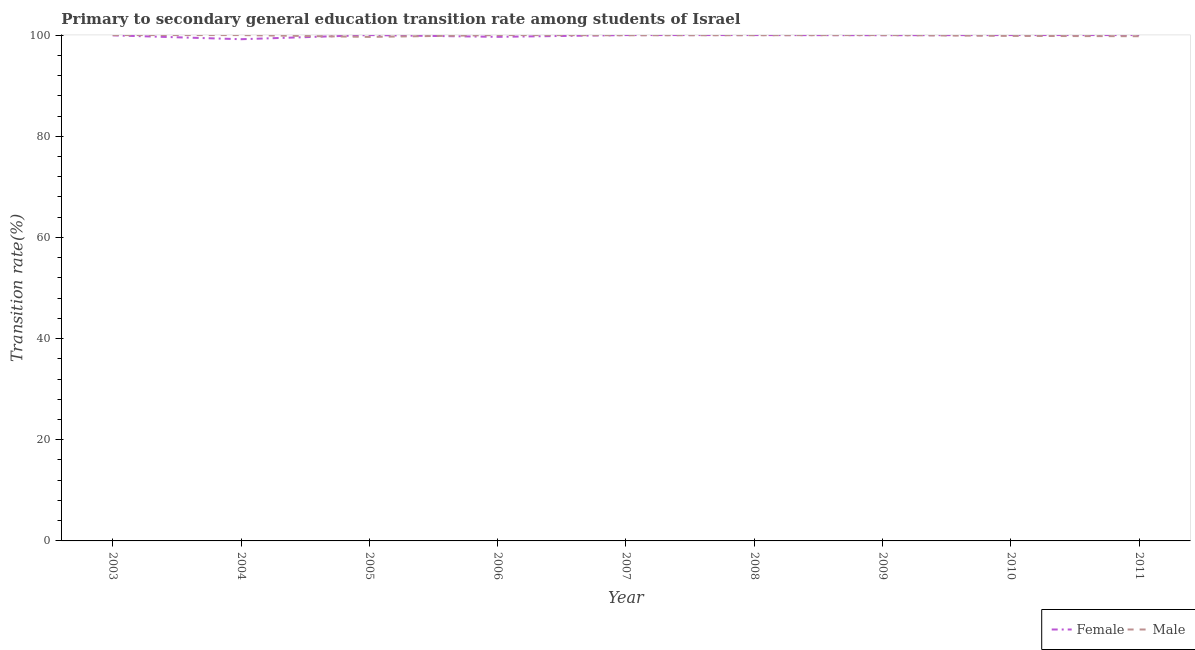How many different coloured lines are there?
Your answer should be compact. 2. Does the line corresponding to transition rate among male students intersect with the line corresponding to transition rate among female students?
Your answer should be very brief. Yes. Across all years, what is the maximum transition rate among male students?
Make the answer very short. 100. Across all years, what is the minimum transition rate among female students?
Ensure brevity in your answer.  99.18. In which year was the transition rate among female students minimum?
Make the answer very short. 2004. What is the total transition rate among male students in the graph?
Make the answer very short. 899.19. What is the difference between the transition rate among male students in 2003 and that in 2005?
Your answer should be compact. 0.36. What is the difference between the transition rate among female students in 2005 and the transition rate among male students in 2003?
Your answer should be very brief. 0. What is the average transition rate among male students per year?
Provide a succinct answer. 99.91. In the year 2008, what is the difference between the transition rate among male students and transition rate among female students?
Give a very brief answer. -0.03. In how many years, is the transition rate among male students greater than 76 %?
Provide a succinct answer. 9. What is the ratio of the transition rate among female students in 2004 to that in 2011?
Offer a very short reply. 0.99. What is the difference between the highest and the second highest transition rate among female students?
Your response must be concise. 0. What is the difference between the highest and the lowest transition rate among female students?
Offer a very short reply. 0.82. Does the transition rate among female students monotonically increase over the years?
Offer a terse response. No. Is the transition rate among male students strictly greater than the transition rate among female students over the years?
Provide a succinct answer. No. What is the difference between two consecutive major ticks on the Y-axis?
Provide a short and direct response. 20. Are the values on the major ticks of Y-axis written in scientific E-notation?
Ensure brevity in your answer.  No. Does the graph contain any zero values?
Keep it short and to the point. No. How many legend labels are there?
Offer a very short reply. 2. What is the title of the graph?
Ensure brevity in your answer.  Primary to secondary general education transition rate among students of Israel. Does "National Visitors" appear as one of the legend labels in the graph?
Provide a short and direct response. No. What is the label or title of the X-axis?
Offer a terse response. Year. What is the label or title of the Y-axis?
Offer a terse response. Transition rate(%). What is the Transition rate(%) in Female in 2003?
Your answer should be very brief. 99.95. What is the Transition rate(%) of Male in 2003?
Ensure brevity in your answer.  100. What is the Transition rate(%) in Female in 2004?
Offer a terse response. 99.18. What is the Transition rate(%) of Male in 2004?
Provide a succinct answer. 100. What is the Transition rate(%) of Male in 2005?
Offer a terse response. 99.64. What is the Transition rate(%) in Female in 2006?
Make the answer very short. 99.65. What is the Transition rate(%) of Male in 2006?
Offer a very short reply. 100. What is the Transition rate(%) in Male in 2007?
Offer a very short reply. 99.96. What is the Transition rate(%) in Female in 2008?
Your response must be concise. 100. What is the Transition rate(%) in Male in 2008?
Keep it short and to the point. 99.97. What is the Transition rate(%) in Female in 2009?
Ensure brevity in your answer.  99.97. What is the Transition rate(%) of Male in 2009?
Your answer should be very brief. 100. What is the Transition rate(%) in Male in 2010?
Provide a short and direct response. 99.84. What is the Transition rate(%) in Male in 2011?
Provide a succinct answer. 99.78. Across all years, what is the minimum Transition rate(%) of Female?
Your response must be concise. 99.18. Across all years, what is the minimum Transition rate(%) of Male?
Provide a short and direct response. 99.64. What is the total Transition rate(%) in Female in the graph?
Your answer should be compact. 898.75. What is the total Transition rate(%) in Male in the graph?
Keep it short and to the point. 899.19. What is the difference between the Transition rate(%) of Female in 2003 and that in 2004?
Offer a terse response. 0.76. What is the difference between the Transition rate(%) in Female in 2003 and that in 2005?
Your answer should be very brief. -0.05. What is the difference between the Transition rate(%) in Male in 2003 and that in 2005?
Keep it short and to the point. 0.36. What is the difference between the Transition rate(%) in Female in 2003 and that in 2006?
Your answer should be very brief. 0.3. What is the difference between the Transition rate(%) in Female in 2003 and that in 2007?
Make the answer very short. -0.05. What is the difference between the Transition rate(%) of Male in 2003 and that in 2007?
Provide a short and direct response. 0.04. What is the difference between the Transition rate(%) in Female in 2003 and that in 2008?
Your response must be concise. -0.05. What is the difference between the Transition rate(%) of Male in 2003 and that in 2008?
Offer a very short reply. 0.03. What is the difference between the Transition rate(%) in Female in 2003 and that in 2009?
Make the answer very short. -0.02. What is the difference between the Transition rate(%) of Male in 2003 and that in 2009?
Offer a very short reply. 0. What is the difference between the Transition rate(%) of Female in 2003 and that in 2010?
Make the answer very short. -0.05. What is the difference between the Transition rate(%) of Male in 2003 and that in 2010?
Provide a short and direct response. 0.16. What is the difference between the Transition rate(%) in Female in 2003 and that in 2011?
Offer a terse response. -0.05. What is the difference between the Transition rate(%) in Male in 2003 and that in 2011?
Your answer should be compact. 0.22. What is the difference between the Transition rate(%) in Female in 2004 and that in 2005?
Your response must be concise. -0.82. What is the difference between the Transition rate(%) in Male in 2004 and that in 2005?
Make the answer very short. 0.36. What is the difference between the Transition rate(%) in Female in 2004 and that in 2006?
Offer a terse response. -0.47. What is the difference between the Transition rate(%) of Male in 2004 and that in 2006?
Give a very brief answer. 0. What is the difference between the Transition rate(%) in Female in 2004 and that in 2007?
Give a very brief answer. -0.82. What is the difference between the Transition rate(%) in Male in 2004 and that in 2007?
Your answer should be very brief. 0.04. What is the difference between the Transition rate(%) of Female in 2004 and that in 2008?
Give a very brief answer. -0.82. What is the difference between the Transition rate(%) of Male in 2004 and that in 2008?
Offer a very short reply. 0.03. What is the difference between the Transition rate(%) of Female in 2004 and that in 2009?
Keep it short and to the point. -0.79. What is the difference between the Transition rate(%) of Female in 2004 and that in 2010?
Ensure brevity in your answer.  -0.82. What is the difference between the Transition rate(%) in Male in 2004 and that in 2010?
Ensure brevity in your answer.  0.16. What is the difference between the Transition rate(%) of Female in 2004 and that in 2011?
Keep it short and to the point. -0.82. What is the difference between the Transition rate(%) in Male in 2004 and that in 2011?
Offer a very short reply. 0.22. What is the difference between the Transition rate(%) of Female in 2005 and that in 2006?
Give a very brief answer. 0.35. What is the difference between the Transition rate(%) in Male in 2005 and that in 2006?
Provide a succinct answer. -0.36. What is the difference between the Transition rate(%) in Female in 2005 and that in 2007?
Keep it short and to the point. 0. What is the difference between the Transition rate(%) of Male in 2005 and that in 2007?
Offer a terse response. -0.32. What is the difference between the Transition rate(%) in Male in 2005 and that in 2008?
Your answer should be compact. -0.33. What is the difference between the Transition rate(%) in Female in 2005 and that in 2009?
Your answer should be compact. 0.03. What is the difference between the Transition rate(%) in Male in 2005 and that in 2009?
Offer a very short reply. -0.36. What is the difference between the Transition rate(%) in Female in 2005 and that in 2010?
Offer a very short reply. 0. What is the difference between the Transition rate(%) in Male in 2005 and that in 2010?
Provide a succinct answer. -0.2. What is the difference between the Transition rate(%) of Female in 2005 and that in 2011?
Your response must be concise. 0. What is the difference between the Transition rate(%) of Male in 2005 and that in 2011?
Make the answer very short. -0.14. What is the difference between the Transition rate(%) of Female in 2006 and that in 2007?
Your response must be concise. -0.35. What is the difference between the Transition rate(%) of Male in 2006 and that in 2007?
Make the answer very short. 0.04. What is the difference between the Transition rate(%) of Female in 2006 and that in 2008?
Ensure brevity in your answer.  -0.35. What is the difference between the Transition rate(%) in Male in 2006 and that in 2008?
Provide a short and direct response. 0.03. What is the difference between the Transition rate(%) of Female in 2006 and that in 2009?
Ensure brevity in your answer.  -0.32. What is the difference between the Transition rate(%) of Male in 2006 and that in 2009?
Provide a short and direct response. 0. What is the difference between the Transition rate(%) in Female in 2006 and that in 2010?
Ensure brevity in your answer.  -0.35. What is the difference between the Transition rate(%) of Male in 2006 and that in 2010?
Offer a very short reply. 0.16. What is the difference between the Transition rate(%) of Female in 2006 and that in 2011?
Offer a very short reply. -0.35. What is the difference between the Transition rate(%) of Male in 2006 and that in 2011?
Keep it short and to the point. 0.22. What is the difference between the Transition rate(%) of Male in 2007 and that in 2008?
Your response must be concise. -0.01. What is the difference between the Transition rate(%) of Female in 2007 and that in 2009?
Your answer should be compact. 0.03. What is the difference between the Transition rate(%) in Male in 2007 and that in 2009?
Give a very brief answer. -0.04. What is the difference between the Transition rate(%) in Female in 2007 and that in 2010?
Your response must be concise. 0. What is the difference between the Transition rate(%) of Male in 2007 and that in 2010?
Your answer should be very brief. 0.13. What is the difference between the Transition rate(%) of Female in 2007 and that in 2011?
Offer a terse response. 0. What is the difference between the Transition rate(%) in Male in 2007 and that in 2011?
Give a very brief answer. 0.19. What is the difference between the Transition rate(%) of Female in 2008 and that in 2009?
Make the answer very short. 0.03. What is the difference between the Transition rate(%) in Male in 2008 and that in 2009?
Your answer should be very brief. -0.03. What is the difference between the Transition rate(%) of Male in 2008 and that in 2010?
Provide a short and direct response. 0.14. What is the difference between the Transition rate(%) of Male in 2008 and that in 2011?
Your answer should be compact. 0.2. What is the difference between the Transition rate(%) in Female in 2009 and that in 2010?
Offer a very short reply. -0.03. What is the difference between the Transition rate(%) of Male in 2009 and that in 2010?
Make the answer very short. 0.16. What is the difference between the Transition rate(%) in Female in 2009 and that in 2011?
Your response must be concise. -0.03. What is the difference between the Transition rate(%) in Male in 2009 and that in 2011?
Give a very brief answer. 0.22. What is the difference between the Transition rate(%) of Female in 2010 and that in 2011?
Offer a terse response. 0. What is the difference between the Transition rate(%) in Male in 2010 and that in 2011?
Your response must be concise. 0.06. What is the difference between the Transition rate(%) in Female in 2003 and the Transition rate(%) in Male in 2004?
Keep it short and to the point. -0.05. What is the difference between the Transition rate(%) in Female in 2003 and the Transition rate(%) in Male in 2005?
Provide a short and direct response. 0.31. What is the difference between the Transition rate(%) of Female in 2003 and the Transition rate(%) of Male in 2006?
Provide a succinct answer. -0.05. What is the difference between the Transition rate(%) of Female in 2003 and the Transition rate(%) of Male in 2007?
Provide a succinct answer. -0.02. What is the difference between the Transition rate(%) of Female in 2003 and the Transition rate(%) of Male in 2008?
Offer a very short reply. -0.03. What is the difference between the Transition rate(%) in Female in 2003 and the Transition rate(%) in Male in 2009?
Give a very brief answer. -0.05. What is the difference between the Transition rate(%) in Female in 2003 and the Transition rate(%) in Male in 2010?
Offer a very short reply. 0.11. What is the difference between the Transition rate(%) of Female in 2003 and the Transition rate(%) of Male in 2011?
Ensure brevity in your answer.  0.17. What is the difference between the Transition rate(%) of Female in 2004 and the Transition rate(%) of Male in 2005?
Your answer should be very brief. -0.46. What is the difference between the Transition rate(%) of Female in 2004 and the Transition rate(%) of Male in 2006?
Provide a succinct answer. -0.82. What is the difference between the Transition rate(%) of Female in 2004 and the Transition rate(%) of Male in 2007?
Give a very brief answer. -0.78. What is the difference between the Transition rate(%) of Female in 2004 and the Transition rate(%) of Male in 2008?
Your answer should be compact. -0.79. What is the difference between the Transition rate(%) of Female in 2004 and the Transition rate(%) of Male in 2009?
Offer a very short reply. -0.82. What is the difference between the Transition rate(%) of Female in 2004 and the Transition rate(%) of Male in 2010?
Keep it short and to the point. -0.65. What is the difference between the Transition rate(%) of Female in 2004 and the Transition rate(%) of Male in 2011?
Offer a terse response. -0.59. What is the difference between the Transition rate(%) of Female in 2005 and the Transition rate(%) of Male in 2006?
Offer a terse response. 0. What is the difference between the Transition rate(%) in Female in 2005 and the Transition rate(%) in Male in 2007?
Your response must be concise. 0.04. What is the difference between the Transition rate(%) in Female in 2005 and the Transition rate(%) in Male in 2008?
Ensure brevity in your answer.  0.03. What is the difference between the Transition rate(%) in Female in 2005 and the Transition rate(%) in Male in 2009?
Your answer should be compact. 0. What is the difference between the Transition rate(%) of Female in 2005 and the Transition rate(%) of Male in 2010?
Offer a very short reply. 0.16. What is the difference between the Transition rate(%) in Female in 2005 and the Transition rate(%) in Male in 2011?
Your answer should be compact. 0.22. What is the difference between the Transition rate(%) in Female in 2006 and the Transition rate(%) in Male in 2007?
Give a very brief answer. -0.31. What is the difference between the Transition rate(%) of Female in 2006 and the Transition rate(%) of Male in 2008?
Make the answer very short. -0.32. What is the difference between the Transition rate(%) in Female in 2006 and the Transition rate(%) in Male in 2009?
Make the answer very short. -0.35. What is the difference between the Transition rate(%) of Female in 2006 and the Transition rate(%) of Male in 2010?
Give a very brief answer. -0.19. What is the difference between the Transition rate(%) in Female in 2006 and the Transition rate(%) in Male in 2011?
Your answer should be very brief. -0.12. What is the difference between the Transition rate(%) of Female in 2007 and the Transition rate(%) of Male in 2008?
Offer a very short reply. 0.03. What is the difference between the Transition rate(%) of Female in 2007 and the Transition rate(%) of Male in 2010?
Ensure brevity in your answer.  0.16. What is the difference between the Transition rate(%) in Female in 2007 and the Transition rate(%) in Male in 2011?
Your response must be concise. 0.22. What is the difference between the Transition rate(%) in Female in 2008 and the Transition rate(%) in Male in 2010?
Offer a very short reply. 0.16. What is the difference between the Transition rate(%) of Female in 2008 and the Transition rate(%) of Male in 2011?
Your answer should be very brief. 0.22. What is the difference between the Transition rate(%) in Female in 2009 and the Transition rate(%) in Male in 2010?
Your answer should be compact. 0.13. What is the difference between the Transition rate(%) of Female in 2009 and the Transition rate(%) of Male in 2011?
Your answer should be very brief. 0.2. What is the difference between the Transition rate(%) of Female in 2010 and the Transition rate(%) of Male in 2011?
Provide a short and direct response. 0.22. What is the average Transition rate(%) of Female per year?
Keep it short and to the point. 99.86. What is the average Transition rate(%) of Male per year?
Your answer should be very brief. 99.91. In the year 2003, what is the difference between the Transition rate(%) of Female and Transition rate(%) of Male?
Offer a very short reply. -0.05. In the year 2004, what is the difference between the Transition rate(%) of Female and Transition rate(%) of Male?
Keep it short and to the point. -0.82. In the year 2005, what is the difference between the Transition rate(%) in Female and Transition rate(%) in Male?
Your response must be concise. 0.36. In the year 2006, what is the difference between the Transition rate(%) of Female and Transition rate(%) of Male?
Offer a terse response. -0.35. In the year 2007, what is the difference between the Transition rate(%) of Female and Transition rate(%) of Male?
Make the answer very short. 0.04. In the year 2008, what is the difference between the Transition rate(%) in Female and Transition rate(%) in Male?
Give a very brief answer. 0.03. In the year 2009, what is the difference between the Transition rate(%) in Female and Transition rate(%) in Male?
Provide a short and direct response. -0.03. In the year 2010, what is the difference between the Transition rate(%) in Female and Transition rate(%) in Male?
Your response must be concise. 0.16. In the year 2011, what is the difference between the Transition rate(%) in Female and Transition rate(%) in Male?
Ensure brevity in your answer.  0.22. What is the ratio of the Transition rate(%) of Female in 2003 to that in 2004?
Give a very brief answer. 1.01. What is the ratio of the Transition rate(%) of Female in 2003 to that in 2005?
Offer a very short reply. 1. What is the ratio of the Transition rate(%) of Female in 2003 to that in 2006?
Keep it short and to the point. 1. What is the ratio of the Transition rate(%) in Male in 2003 to that in 2006?
Ensure brevity in your answer.  1. What is the ratio of the Transition rate(%) in Female in 2003 to that in 2007?
Your answer should be compact. 1. What is the ratio of the Transition rate(%) in Male in 2003 to that in 2007?
Give a very brief answer. 1. What is the ratio of the Transition rate(%) of Male in 2003 to that in 2010?
Give a very brief answer. 1. What is the ratio of the Transition rate(%) of Female in 2003 to that in 2011?
Give a very brief answer. 1. What is the ratio of the Transition rate(%) in Female in 2004 to that in 2005?
Offer a terse response. 0.99. What is the ratio of the Transition rate(%) of Male in 2004 to that in 2005?
Provide a short and direct response. 1. What is the ratio of the Transition rate(%) in Female in 2004 to that in 2006?
Offer a very short reply. 1. What is the ratio of the Transition rate(%) in Male in 2004 to that in 2008?
Your response must be concise. 1. What is the ratio of the Transition rate(%) of Male in 2004 to that in 2009?
Your answer should be very brief. 1. What is the ratio of the Transition rate(%) of Male in 2004 to that in 2010?
Your answer should be very brief. 1. What is the ratio of the Transition rate(%) of Male in 2005 to that in 2007?
Your answer should be very brief. 1. What is the ratio of the Transition rate(%) of Female in 2005 to that in 2008?
Offer a terse response. 1. What is the ratio of the Transition rate(%) in Male in 2005 to that in 2008?
Provide a succinct answer. 1. What is the ratio of the Transition rate(%) of Male in 2005 to that in 2010?
Keep it short and to the point. 1. What is the ratio of the Transition rate(%) in Male in 2005 to that in 2011?
Give a very brief answer. 1. What is the ratio of the Transition rate(%) of Female in 2006 to that in 2007?
Offer a terse response. 1. What is the ratio of the Transition rate(%) in Male in 2006 to that in 2007?
Ensure brevity in your answer.  1. What is the ratio of the Transition rate(%) of Male in 2006 to that in 2008?
Provide a short and direct response. 1. What is the ratio of the Transition rate(%) in Female in 2006 to that in 2009?
Your response must be concise. 1. What is the ratio of the Transition rate(%) of Female in 2006 to that in 2010?
Provide a succinct answer. 1. What is the ratio of the Transition rate(%) in Female in 2006 to that in 2011?
Offer a very short reply. 1. What is the ratio of the Transition rate(%) in Male in 2006 to that in 2011?
Provide a succinct answer. 1. What is the ratio of the Transition rate(%) of Male in 2007 to that in 2008?
Your answer should be compact. 1. What is the ratio of the Transition rate(%) of Male in 2007 to that in 2009?
Ensure brevity in your answer.  1. What is the ratio of the Transition rate(%) of Female in 2007 to that in 2010?
Ensure brevity in your answer.  1. What is the ratio of the Transition rate(%) in Male in 2007 to that in 2010?
Give a very brief answer. 1. What is the ratio of the Transition rate(%) in Male in 2007 to that in 2011?
Your answer should be compact. 1. What is the ratio of the Transition rate(%) of Male in 2008 to that in 2010?
Make the answer very short. 1. What is the ratio of the Transition rate(%) in Male in 2008 to that in 2011?
Offer a very short reply. 1. What is the ratio of the Transition rate(%) of Male in 2009 to that in 2010?
Offer a terse response. 1. What is the ratio of the Transition rate(%) in Female in 2009 to that in 2011?
Your answer should be compact. 1. What is the difference between the highest and the second highest Transition rate(%) in Female?
Make the answer very short. 0. What is the difference between the highest and the second highest Transition rate(%) in Male?
Provide a short and direct response. 0. What is the difference between the highest and the lowest Transition rate(%) in Female?
Your answer should be very brief. 0.82. What is the difference between the highest and the lowest Transition rate(%) of Male?
Your answer should be very brief. 0.36. 